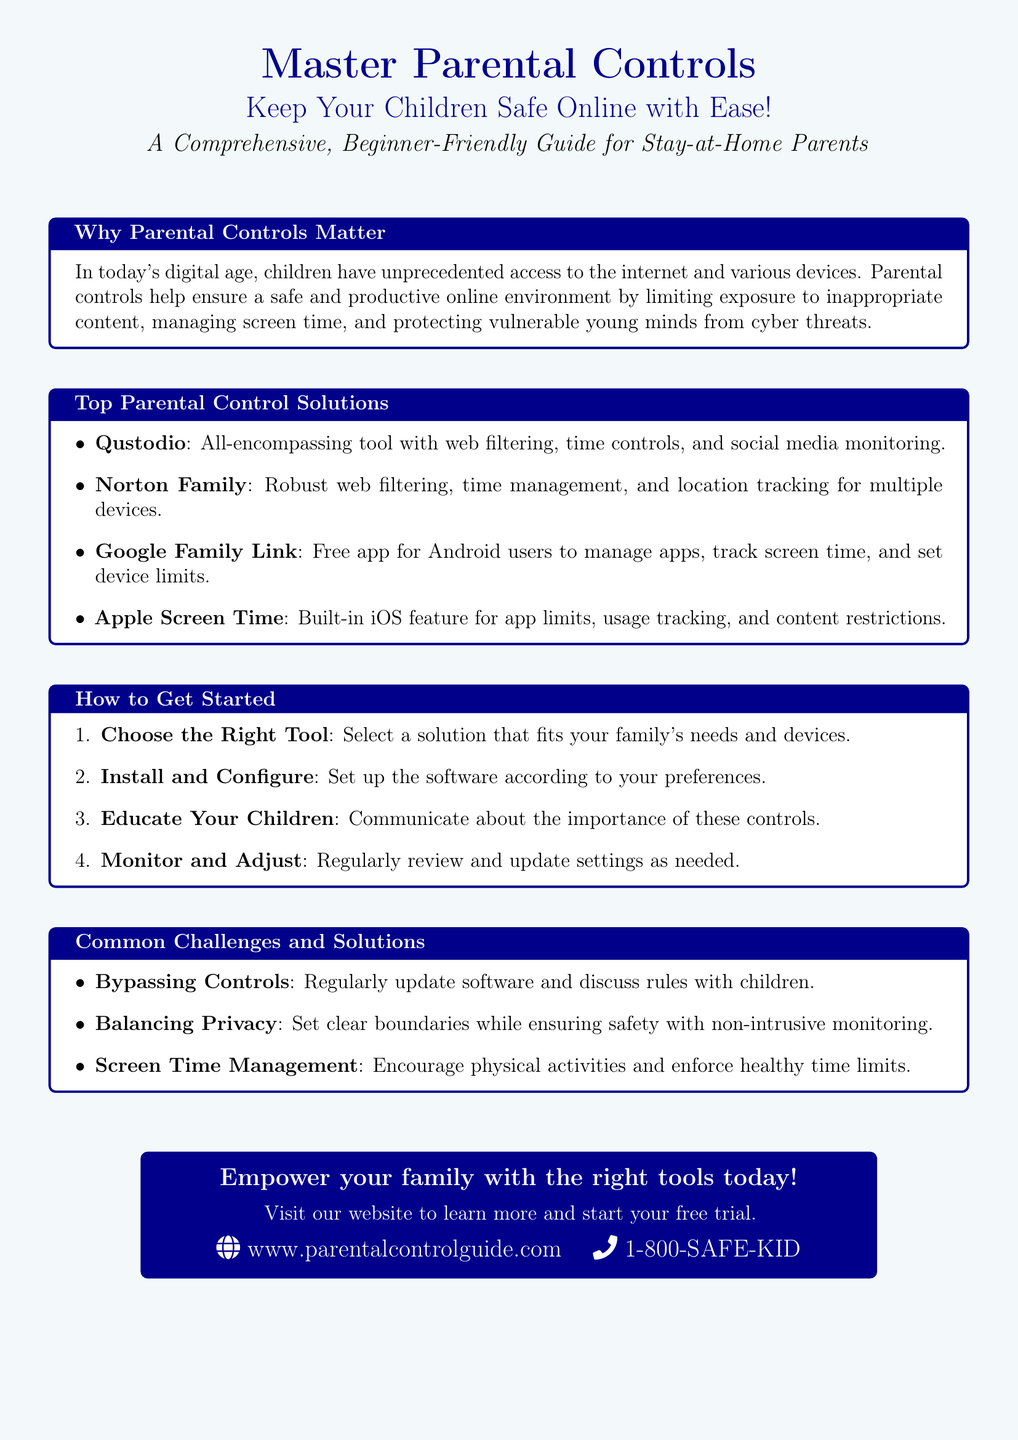What is the title of the guide? The title of the guide is prominently displayed at the top of the document.
Answer: Master Parental Controls What does the document encourage parents to do? The document mentions that it is aimed at keeping children safe online, showing its purpose.
Answer: Keep Your Children Safe Online Which tool is described as a free app for Android users? The document includes a list of parental control solutions, highlighting this specific tool's functionality.
Answer: Google Family Link What is the first step in getting started with parental controls? The document outlines a specific procedure to begin applying parental controls, starting with the selection process.
Answer: Choose the Right Tool What is one common challenge mentioned in the document? The document lists various challenges related to parental control implementation, demonstrating the difficulties that may arise.
Answer: Bypassing Controls What website is provided for further information? The document includes a specific URL for parents to visit to learn more about parental control solutions.
Answer: www.parentalcontrolguide.com What is one suggested way to manage screen time? The document mentions a practical approach to ensure healthy screen time limits, highlighting parental guidance.
Answer: Encourage physical activities Which solution provides location tracking for multiple devices? The list of top solutions includes a feature that specifically mentions this tracking capability.
Answer: Norton Family What is emphasized about educating children regarding parental controls? The document states an important aspect of engaging children in the process to promote understanding and compliance.
Answer: Communicate about the importance of these controls 